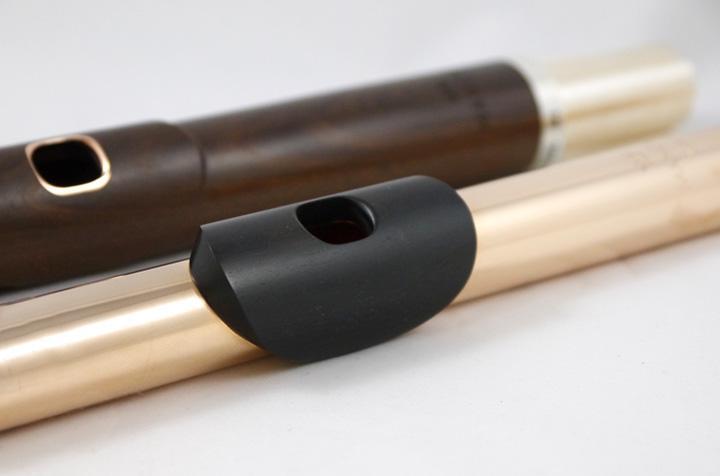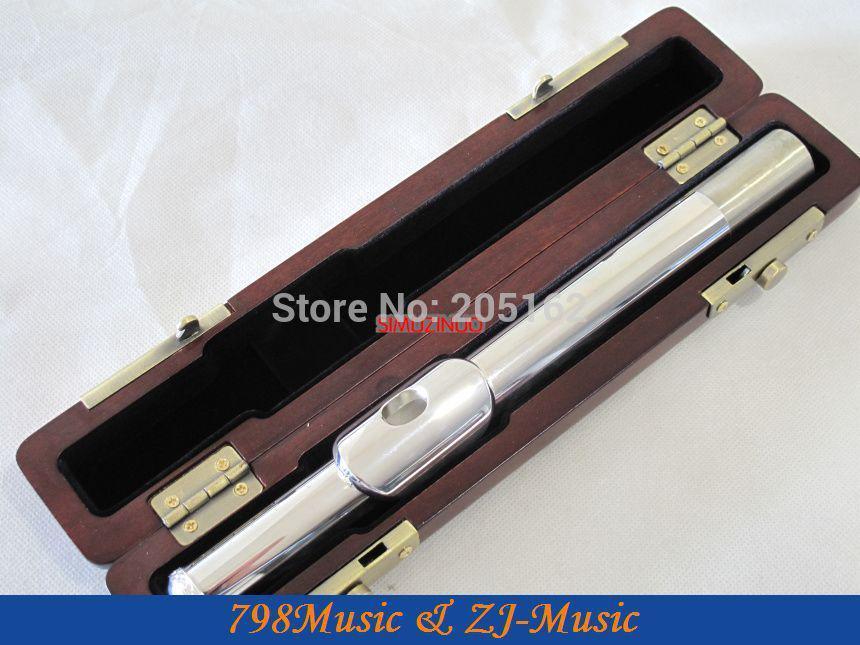The first image is the image on the left, the second image is the image on the right. Considering the images on both sides, is "In at least one image there is a single close flute case sitting on the ground." valid? Answer yes or no. No. The first image is the image on the left, the second image is the image on the right. Assess this claim about the two images: "The combined images include one closed instrument case and three flute parts.". Correct or not? Answer yes or no. No. 